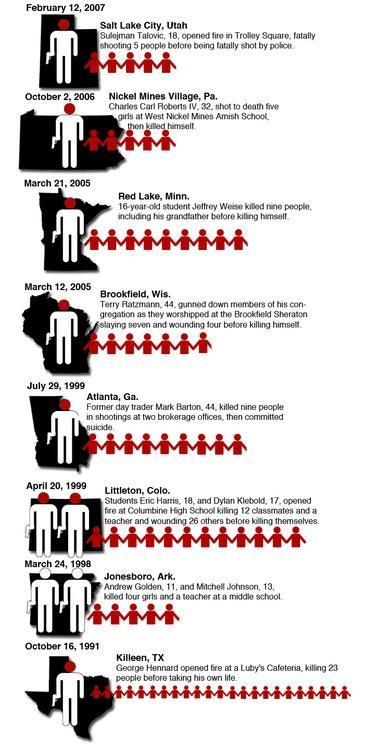Which place reported the number of causalities as 12 ?
Answer the question with a short phrase. Littleton, Colo. How many shooting incidents were reported in 1999? 2 Which year had the highest number of causalities due the shooting incidents? 1991 What was the age of the shooter in Atlanta? 44 How many shooting incidents were reported in 2005? 2 Where did the shooting incident at Colorado take place, Trolley Square, West Nickel Amish school, or Columbine High school? Columbine High school When did the shooting incident in Minnesota take place? March 12, 2005 How many shooters were aged 18 or below? 6 When did the shooting incident in Texas take place? October 16, 1991 